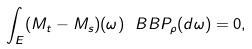Convert formula to latex. <formula><loc_0><loc_0><loc_500><loc_500>\int _ { E } ( M _ { t } - M _ { s } ) ( \omega ) \ B B { P _ { \rho } } ( d \omega ) = 0 ,</formula> 